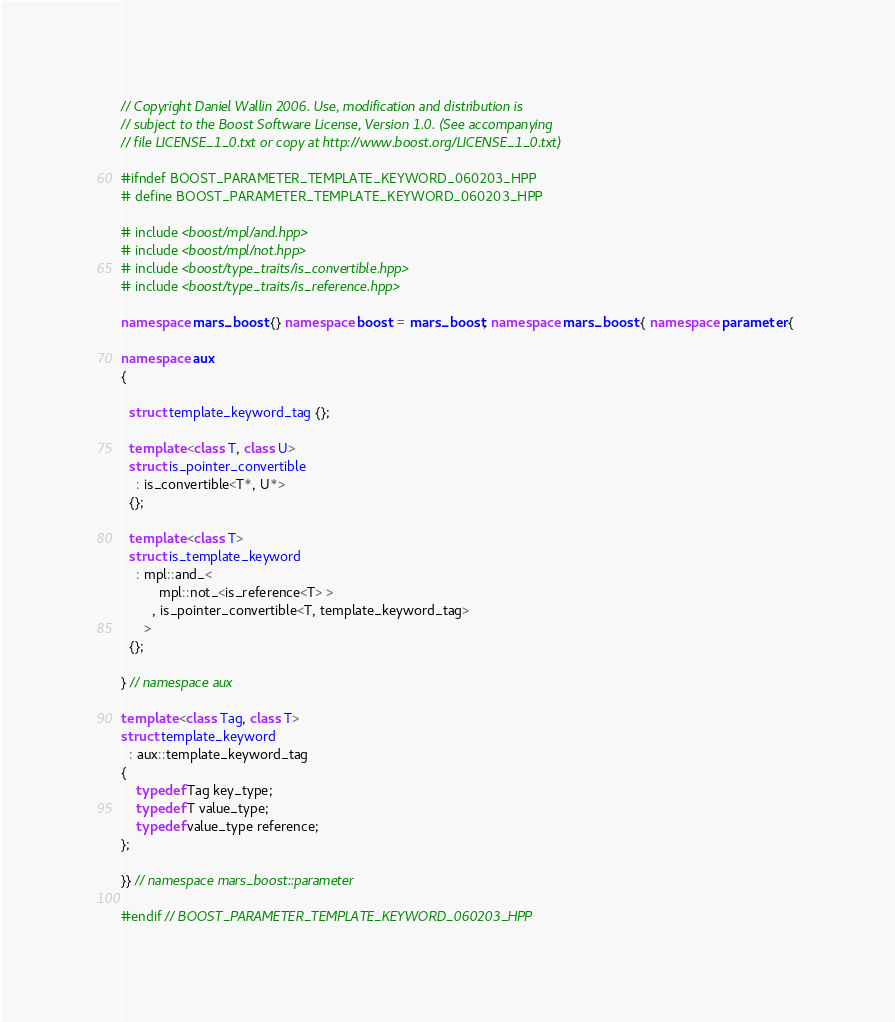Convert code to text. <code><loc_0><loc_0><loc_500><loc_500><_C++_>// Copyright Daniel Wallin 2006. Use, modification and distribution is
// subject to the Boost Software License, Version 1.0. (See accompanying
// file LICENSE_1_0.txt or copy at http://www.boost.org/LICENSE_1_0.txt)

#ifndef BOOST_PARAMETER_TEMPLATE_KEYWORD_060203_HPP
# define BOOST_PARAMETER_TEMPLATE_KEYWORD_060203_HPP

# include <boost/mpl/and.hpp>
# include <boost/mpl/not.hpp>
# include <boost/type_traits/is_convertible.hpp>
# include <boost/type_traits/is_reference.hpp>

namespace mars_boost {} namespace boost = mars_boost; namespace mars_boost { namespace parameter { 

namespace aux 
{

  struct template_keyword_tag {}; 

  template <class T, class U>
  struct is_pointer_convertible
    : is_convertible<T*, U*>
  {};

  template <class T>
  struct is_template_keyword
    : mpl::and_<
          mpl::not_<is_reference<T> >
        , is_pointer_convertible<T, template_keyword_tag>
      >
  {};

} // namespace aux

template <class Tag, class T>
struct template_keyword
  : aux::template_keyword_tag
{
    typedef Tag key_type;
    typedef T value_type;
    typedef value_type reference;
};

}} // namespace mars_boost::parameter

#endif // BOOST_PARAMETER_TEMPLATE_KEYWORD_060203_HPP

</code> 